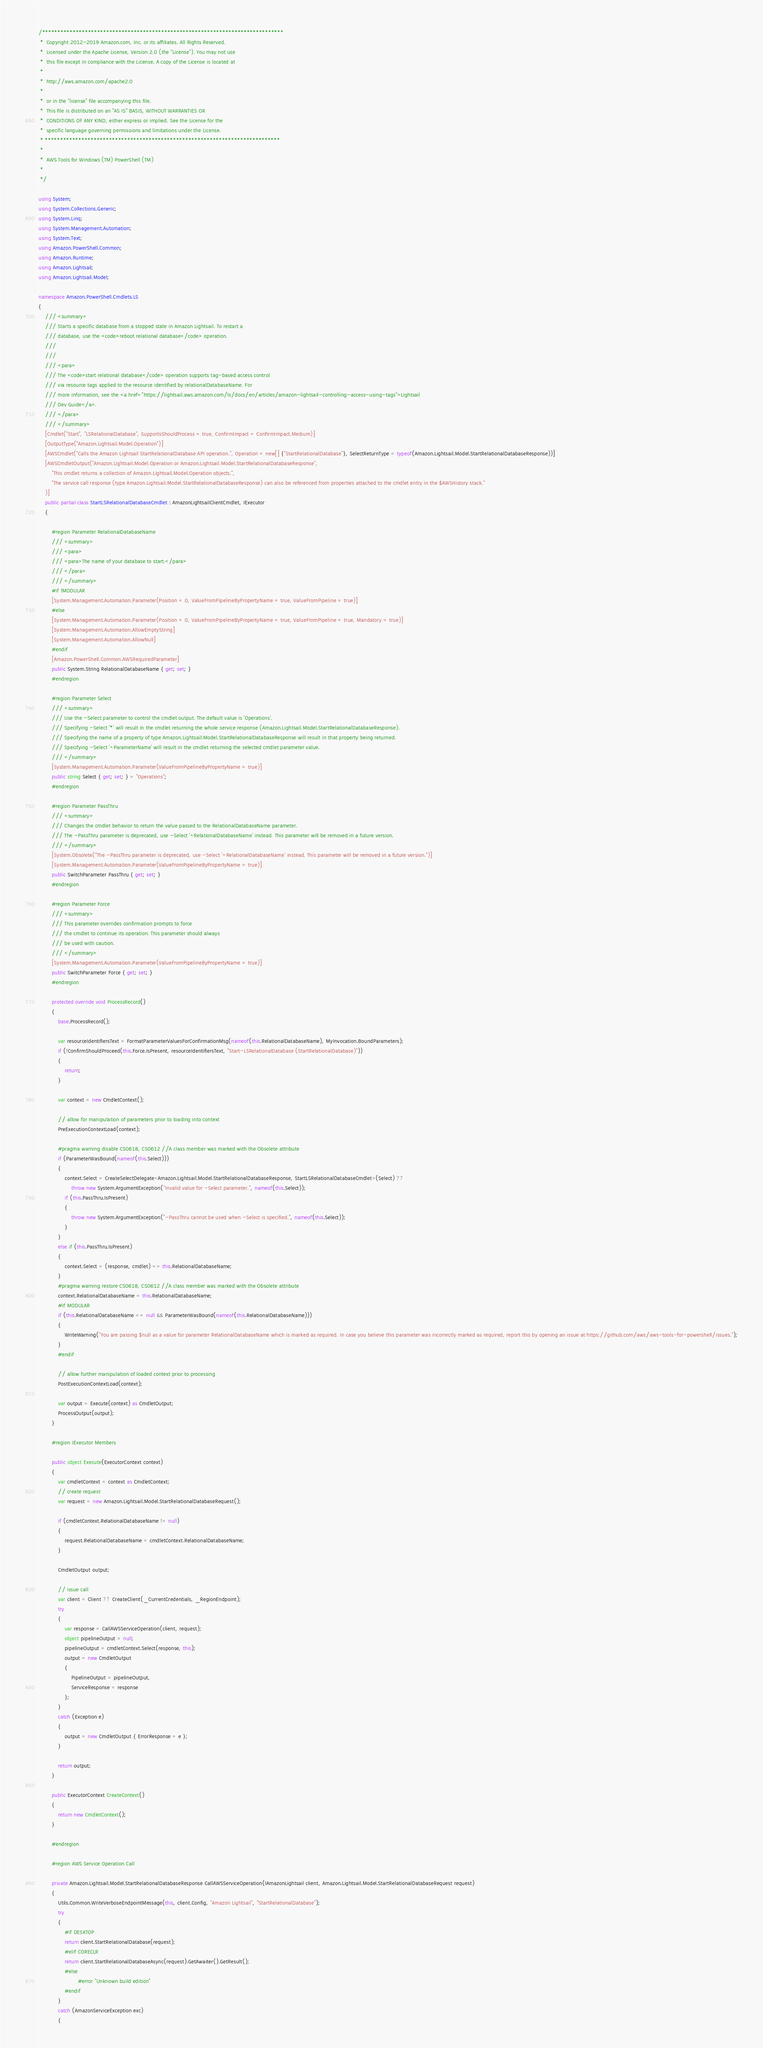<code> <loc_0><loc_0><loc_500><loc_500><_C#_>/*******************************************************************************
 *  Copyright 2012-2019 Amazon.com, Inc. or its affiliates. All Rights Reserved.
 *  Licensed under the Apache License, Version 2.0 (the "License"). You may not use
 *  this file except in compliance with the License. A copy of the License is located at
 *
 *  http://aws.amazon.com/apache2.0
 *
 *  or in the "license" file accompanying this file.
 *  This file is distributed on an "AS IS" BASIS, WITHOUT WARRANTIES OR
 *  CONDITIONS OF ANY KIND, either express or implied. See the License for the
 *  specific language governing permissions and limitations under the License.
 * *****************************************************************************
 *
 *  AWS Tools for Windows (TM) PowerShell (TM)
 *
 */

using System;
using System.Collections.Generic;
using System.Linq;
using System.Management.Automation;
using System.Text;
using Amazon.PowerShell.Common;
using Amazon.Runtime;
using Amazon.Lightsail;
using Amazon.Lightsail.Model;

namespace Amazon.PowerShell.Cmdlets.LS
{
    /// <summary>
    /// Starts a specific database from a stopped state in Amazon Lightsail. To restart a
    /// database, use the <code>reboot relational database</code> operation.
    /// 
    ///  
    /// <para>
    /// The <code>start relational database</code> operation supports tag-based access control
    /// via resource tags applied to the resource identified by relationalDatabaseName. For
    /// more information, see the <a href="https://lightsail.aws.amazon.com/ls/docs/en/articles/amazon-lightsail-controlling-access-using-tags">Lightsail
    /// Dev Guide</a>.
    /// </para>
    /// </summary>
    [Cmdlet("Start", "LSRelationalDatabase", SupportsShouldProcess = true, ConfirmImpact = ConfirmImpact.Medium)]
    [OutputType("Amazon.Lightsail.Model.Operation")]
    [AWSCmdlet("Calls the Amazon Lightsail StartRelationalDatabase API operation.", Operation = new[] {"StartRelationalDatabase"}, SelectReturnType = typeof(Amazon.Lightsail.Model.StartRelationalDatabaseResponse))]
    [AWSCmdletOutput("Amazon.Lightsail.Model.Operation or Amazon.Lightsail.Model.StartRelationalDatabaseResponse",
        "This cmdlet returns a collection of Amazon.Lightsail.Model.Operation objects.",
        "The service call response (type Amazon.Lightsail.Model.StartRelationalDatabaseResponse) can also be referenced from properties attached to the cmdlet entry in the $AWSHistory stack."
    )]
    public partial class StartLSRelationalDatabaseCmdlet : AmazonLightsailClientCmdlet, IExecutor
    {
        
        #region Parameter RelationalDatabaseName
        /// <summary>
        /// <para>
        /// <para>The name of your database to start.</para>
        /// </para>
        /// </summary>
        #if !MODULAR
        [System.Management.Automation.Parameter(Position = 0, ValueFromPipelineByPropertyName = true, ValueFromPipeline = true)]
        #else
        [System.Management.Automation.Parameter(Position = 0, ValueFromPipelineByPropertyName = true, ValueFromPipeline = true, Mandatory = true)]
        [System.Management.Automation.AllowEmptyString]
        [System.Management.Automation.AllowNull]
        #endif
        [Amazon.PowerShell.Common.AWSRequiredParameter]
        public System.String RelationalDatabaseName { get; set; }
        #endregion
        
        #region Parameter Select
        /// <summary>
        /// Use the -Select parameter to control the cmdlet output. The default value is 'Operations'.
        /// Specifying -Select '*' will result in the cmdlet returning the whole service response (Amazon.Lightsail.Model.StartRelationalDatabaseResponse).
        /// Specifying the name of a property of type Amazon.Lightsail.Model.StartRelationalDatabaseResponse will result in that property being returned.
        /// Specifying -Select '^ParameterName' will result in the cmdlet returning the selected cmdlet parameter value.
        /// </summary>
        [System.Management.Automation.Parameter(ValueFromPipelineByPropertyName = true)]
        public string Select { get; set; } = "Operations";
        #endregion
        
        #region Parameter PassThru
        /// <summary>
        /// Changes the cmdlet behavior to return the value passed to the RelationalDatabaseName parameter.
        /// The -PassThru parameter is deprecated, use -Select '^RelationalDatabaseName' instead. This parameter will be removed in a future version.
        /// </summary>
        [System.Obsolete("The -PassThru parameter is deprecated, use -Select '^RelationalDatabaseName' instead. This parameter will be removed in a future version.")]
        [System.Management.Automation.Parameter(ValueFromPipelineByPropertyName = true)]
        public SwitchParameter PassThru { get; set; }
        #endregion
        
        #region Parameter Force
        /// <summary>
        /// This parameter overrides confirmation prompts to force 
        /// the cmdlet to continue its operation. This parameter should always
        /// be used with caution.
        /// </summary>
        [System.Management.Automation.Parameter(ValueFromPipelineByPropertyName = true)]
        public SwitchParameter Force { get; set; }
        #endregion
        
        protected override void ProcessRecord()
        {
            base.ProcessRecord();
            
            var resourceIdentifiersText = FormatParameterValuesForConfirmationMsg(nameof(this.RelationalDatabaseName), MyInvocation.BoundParameters);
            if (!ConfirmShouldProceed(this.Force.IsPresent, resourceIdentifiersText, "Start-LSRelationalDatabase (StartRelationalDatabase)"))
            {
                return;
            }
            
            var context = new CmdletContext();
            
            // allow for manipulation of parameters prior to loading into context
            PreExecutionContextLoad(context);
            
            #pragma warning disable CS0618, CS0612 //A class member was marked with the Obsolete attribute
            if (ParameterWasBound(nameof(this.Select)))
            {
                context.Select = CreateSelectDelegate<Amazon.Lightsail.Model.StartRelationalDatabaseResponse, StartLSRelationalDatabaseCmdlet>(Select) ??
                    throw new System.ArgumentException("Invalid value for -Select parameter.", nameof(this.Select));
                if (this.PassThru.IsPresent)
                {
                    throw new System.ArgumentException("-PassThru cannot be used when -Select is specified.", nameof(this.Select));
                }
            }
            else if (this.PassThru.IsPresent)
            {
                context.Select = (response, cmdlet) => this.RelationalDatabaseName;
            }
            #pragma warning restore CS0618, CS0612 //A class member was marked with the Obsolete attribute
            context.RelationalDatabaseName = this.RelationalDatabaseName;
            #if MODULAR
            if (this.RelationalDatabaseName == null && ParameterWasBound(nameof(this.RelationalDatabaseName)))
            {
                WriteWarning("You are passing $null as a value for parameter RelationalDatabaseName which is marked as required. In case you believe this parameter was incorrectly marked as required, report this by opening an issue at https://github.com/aws/aws-tools-for-powershell/issues.");
            }
            #endif
            
            // allow further manipulation of loaded context prior to processing
            PostExecutionContextLoad(context);
            
            var output = Execute(context) as CmdletOutput;
            ProcessOutput(output);
        }
        
        #region IExecutor Members
        
        public object Execute(ExecutorContext context)
        {
            var cmdletContext = context as CmdletContext;
            // create request
            var request = new Amazon.Lightsail.Model.StartRelationalDatabaseRequest();
            
            if (cmdletContext.RelationalDatabaseName != null)
            {
                request.RelationalDatabaseName = cmdletContext.RelationalDatabaseName;
            }
            
            CmdletOutput output;
            
            // issue call
            var client = Client ?? CreateClient(_CurrentCredentials, _RegionEndpoint);
            try
            {
                var response = CallAWSServiceOperation(client, request);
                object pipelineOutput = null;
                pipelineOutput = cmdletContext.Select(response, this);
                output = new CmdletOutput
                {
                    PipelineOutput = pipelineOutput,
                    ServiceResponse = response
                };
            }
            catch (Exception e)
            {
                output = new CmdletOutput { ErrorResponse = e };
            }
            
            return output;
        }
        
        public ExecutorContext CreateContext()
        {
            return new CmdletContext();
        }
        
        #endregion
        
        #region AWS Service Operation Call
        
        private Amazon.Lightsail.Model.StartRelationalDatabaseResponse CallAWSServiceOperation(IAmazonLightsail client, Amazon.Lightsail.Model.StartRelationalDatabaseRequest request)
        {
            Utils.Common.WriteVerboseEndpointMessage(this, client.Config, "Amazon Lightsail", "StartRelationalDatabase");
            try
            {
                #if DESKTOP
                return client.StartRelationalDatabase(request);
                #elif CORECLR
                return client.StartRelationalDatabaseAsync(request).GetAwaiter().GetResult();
                #else
                        #error "Unknown build edition"
                #endif
            }
            catch (AmazonServiceException exc)
            {</code> 